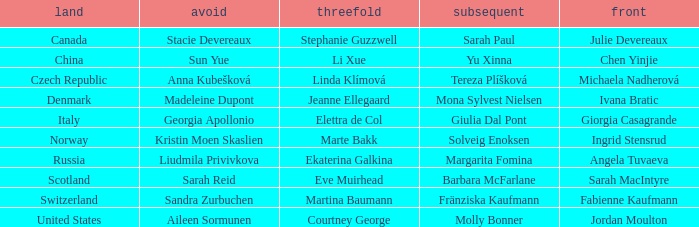What skip has angela tuvaeva as the lead? Liudmila Privivkova. 